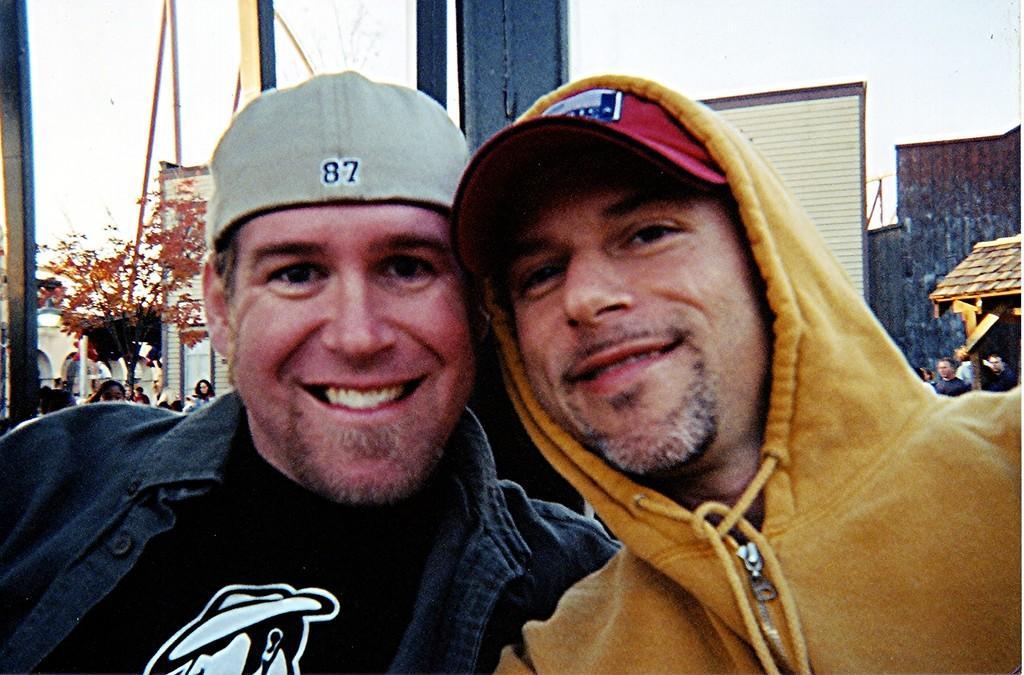In one or two sentences, can you explain what this image depicts? In the front of the image we can see two people. In the background there is a tree, rods, walls, roof, building, pole, people, sky and things. 